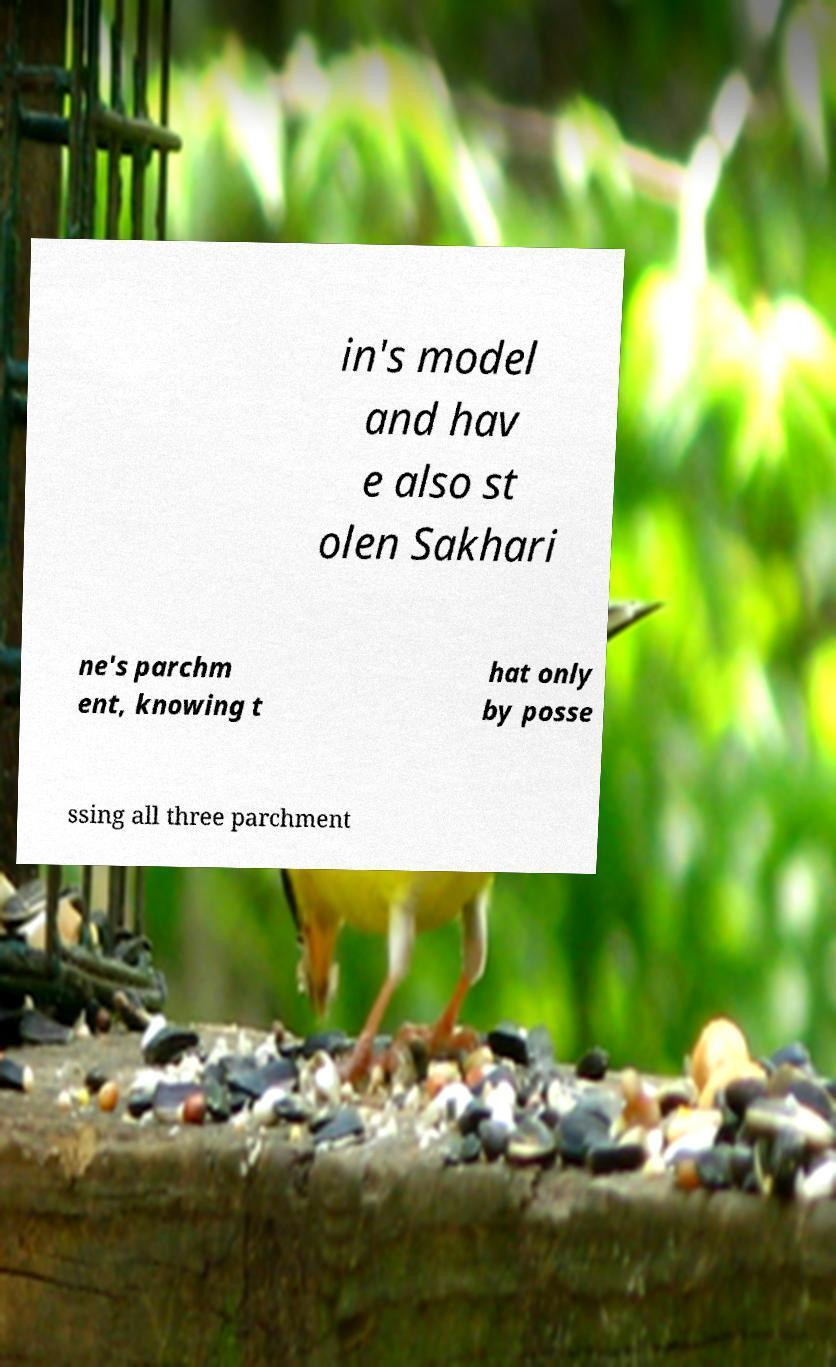Please read and relay the text visible in this image. What does it say? in's model and hav e also st olen Sakhari ne's parchm ent, knowing t hat only by posse ssing all three parchment 